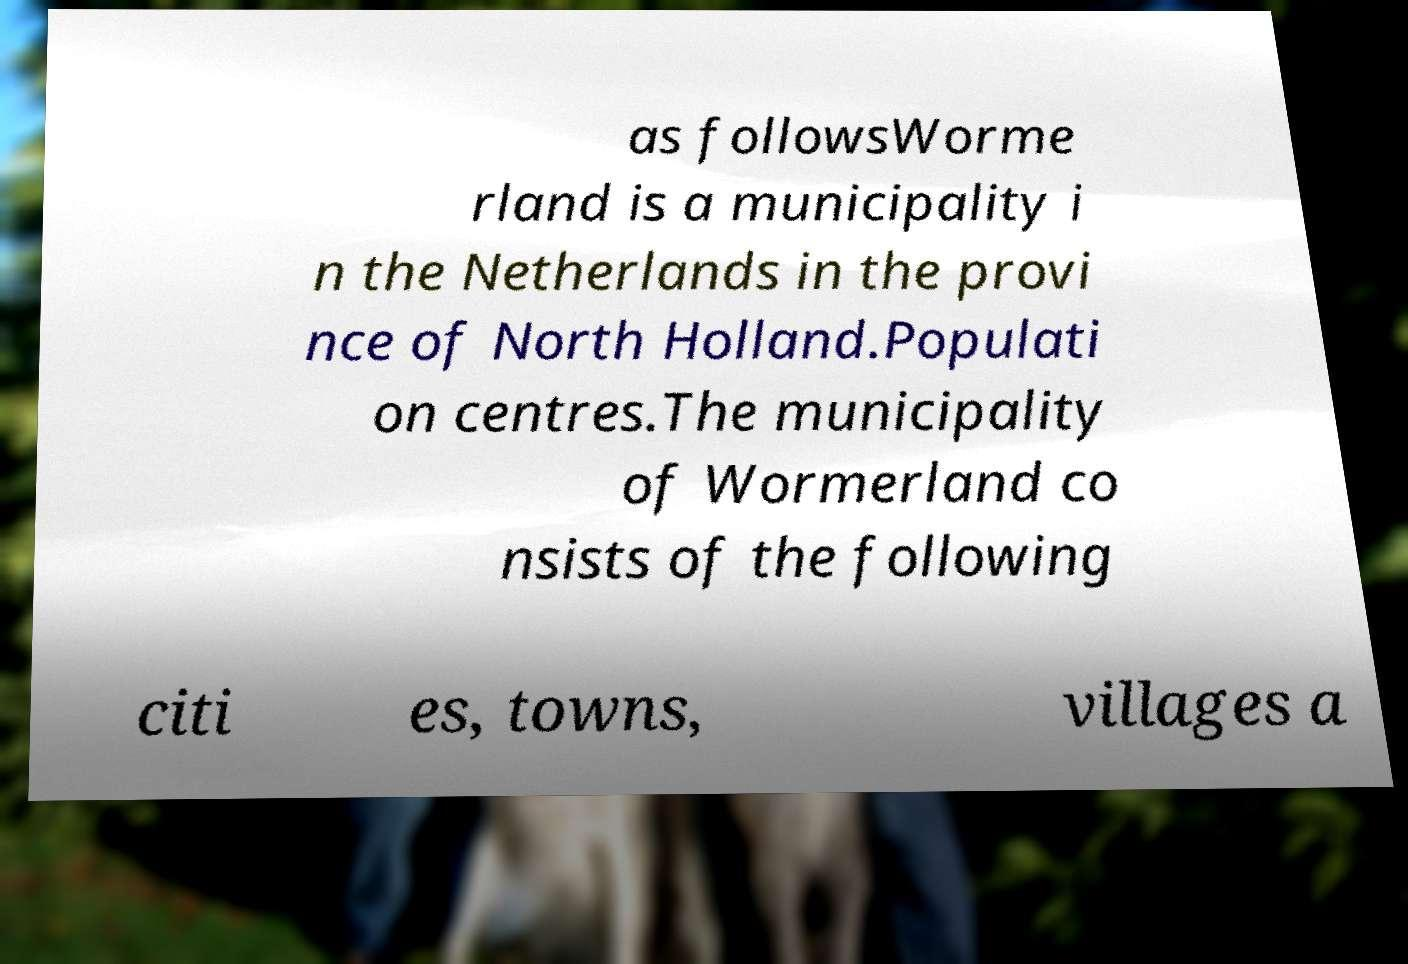Can you read and provide the text displayed in the image?This photo seems to have some interesting text. Can you extract and type it out for me? as followsWorme rland is a municipality i n the Netherlands in the provi nce of North Holland.Populati on centres.The municipality of Wormerland co nsists of the following citi es, towns, villages a 